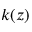Convert formula to latex. <formula><loc_0><loc_0><loc_500><loc_500>k ( z )</formula> 